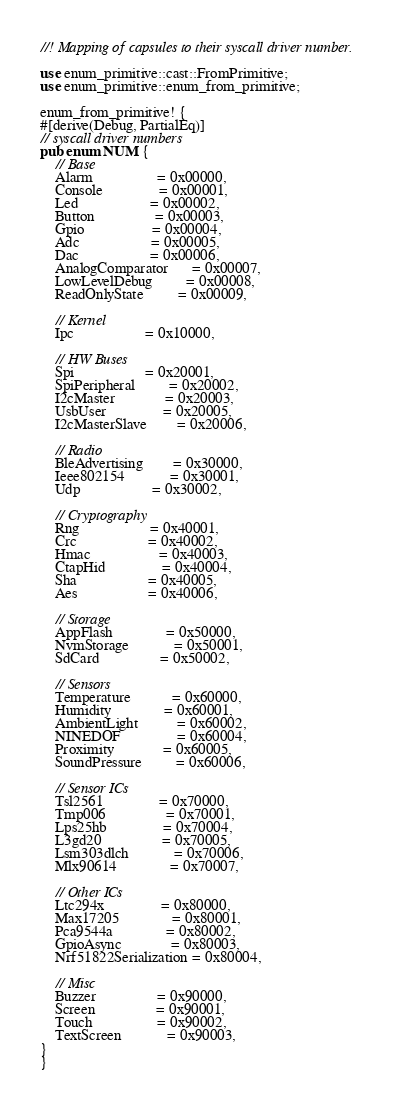<code> <loc_0><loc_0><loc_500><loc_500><_Rust_>//! Mapping of capsules to their syscall driver number.

use enum_primitive::cast::FromPrimitive;
use enum_primitive::enum_from_primitive;

enum_from_primitive! {
#[derive(Debug, PartialEq)]
// syscall driver numbers
pub enum NUM {
    // Base
    Alarm                 = 0x00000,
    Console               = 0x00001,
    Led                   = 0x00002,
    Button                = 0x00003,
    Gpio                  = 0x00004,
    Adc                   = 0x00005,
    Dac                   = 0x00006,
    AnalogComparator      = 0x00007,
    LowLevelDebug         = 0x00008,
    ReadOnlyState         = 0x00009,

    // Kernel
    Ipc                   = 0x10000,

    // HW Buses
    Spi                   = 0x20001,
    SpiPeripheral         = 0x20002,
    I2cMaster             = 0x20003,
    UsbUser               = 0x20005,
    I2cMasterSlave        = 0x20006,

    // Radio
    BleAdvertising        = 0x30000,
    Ieee802154            = 0x30001,
    Udp                   = 0x30002,

    // Cryptography
    Rng                   = 0x40001,
    Crc                   = 0x40002,
    Hmac                  = 0x40003,
    CtapHid               = 0x40004,
    Sha                   = 0x40005,
    Aes                   = 0x40006,

    // Storage
    AppFlash              = 0x50000,
    NvmStorage            = 0x50001,
    SdCard                = 0x50002,

    // Sensors
    Temperature           = 0x60000,
    Humidity              = 0x60001,
    AmbientLight          = 0x60002,
    NINEDOF               = 0x60004,
    Proximity             = 0x60005,
    SoundPressure         = 0x60006,

    // Sensor ICs
    Tsl2561               = 0x70000,
    Tmp006                = 0x70001,
    Lps25hb               = 0x70004,
    L3gd20                = 0x70005,
    Lsm303dlch            = 0x70006,
    Mlx90614              = 0x70007,

    // Other ICs
    Ltc294x               = 0x80000,
    Max17205              = 0x80001,
    Pca9544a              = 0x80002,
    GpioAsync             = 0x80003,
    Nrf51822Serialization = 0x80004,

    // Misc
    Buzzer                = 0x90000,
    Screen                = 0x90001,
    Touch                 = 0x90002,
    TextScreen            = 0x90003,
}
}
</code> 